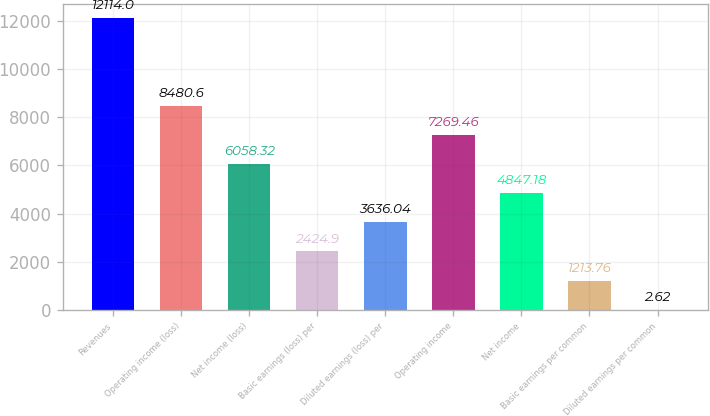Convert chart to OTSL. <chart><loc_0><loc_0><loc_500><loc_500><bar_chart><fcel>Revenues<fcel>Operating income (loss)<fcel>Net income (loss)<fcel>Basic earnings (loss) per<fcel>Diluted earnings (loss) per<fcel>Operating income<fcel>Net income<fcel>Basic earnings per common<fcel>Diluted earnings per common<nl><fcel>12114<fcel>8480.6<fcel>6058.32<fcel>2424.9<fcel>3636.04<fcel>7269.46<fcel>4847.18<fcel>1213.76<fcel>2.62<nl></chart> 